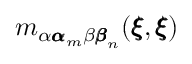<formula> <loc_0><loc_0><loc_500><loc_500>m _ { \alpha { \pm b \alpha } _ { m } \beta { \pm b \beta } _ { n } } ( { \pm b \xi } , { \pm b \xi } )</formula> 